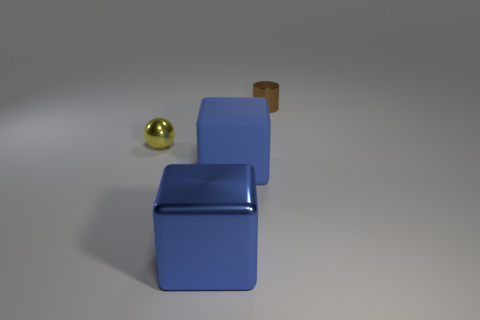How big is the shiny thing that is behind the small metal thing that is in front of the object that is behind the small yellow object?
Give a very brief answer. Small. There is a metal cylinder that is the same size as the yellow shiny object; what is its color?
Provide a short and direct response. Brown. The other thing that is the same color as the matte object is what shape?
Your answer should be compact. Cube. Is the shape of the matte thing the same as the large shiny thing?
Offer a terse response. Yes. What is the thing that is behind the big blue metallic block and in front of the yellow thing made of?
Provide a short and direct response. Rubber. What is the size of the yellow metal object?
Give a very brief answer. Small. There is another thing that is the same shape as the big blue metal thing; what is its color?
Make the answer very short. Blue. Is there any other thing of the same color as the big matte object?
Your answer should be very brief. Yes. Is the size of the object that is behind the tiny yellow metal thing the same as the cube that is left of the rubber thing?
Ensure brevity in your answer.  No. Are there an equal number of large shiny cubes that are behind the brown shiny object and small brown objects that are on the left side of the tiny yellow metallic ball?
Make the answer very short. Yes. 